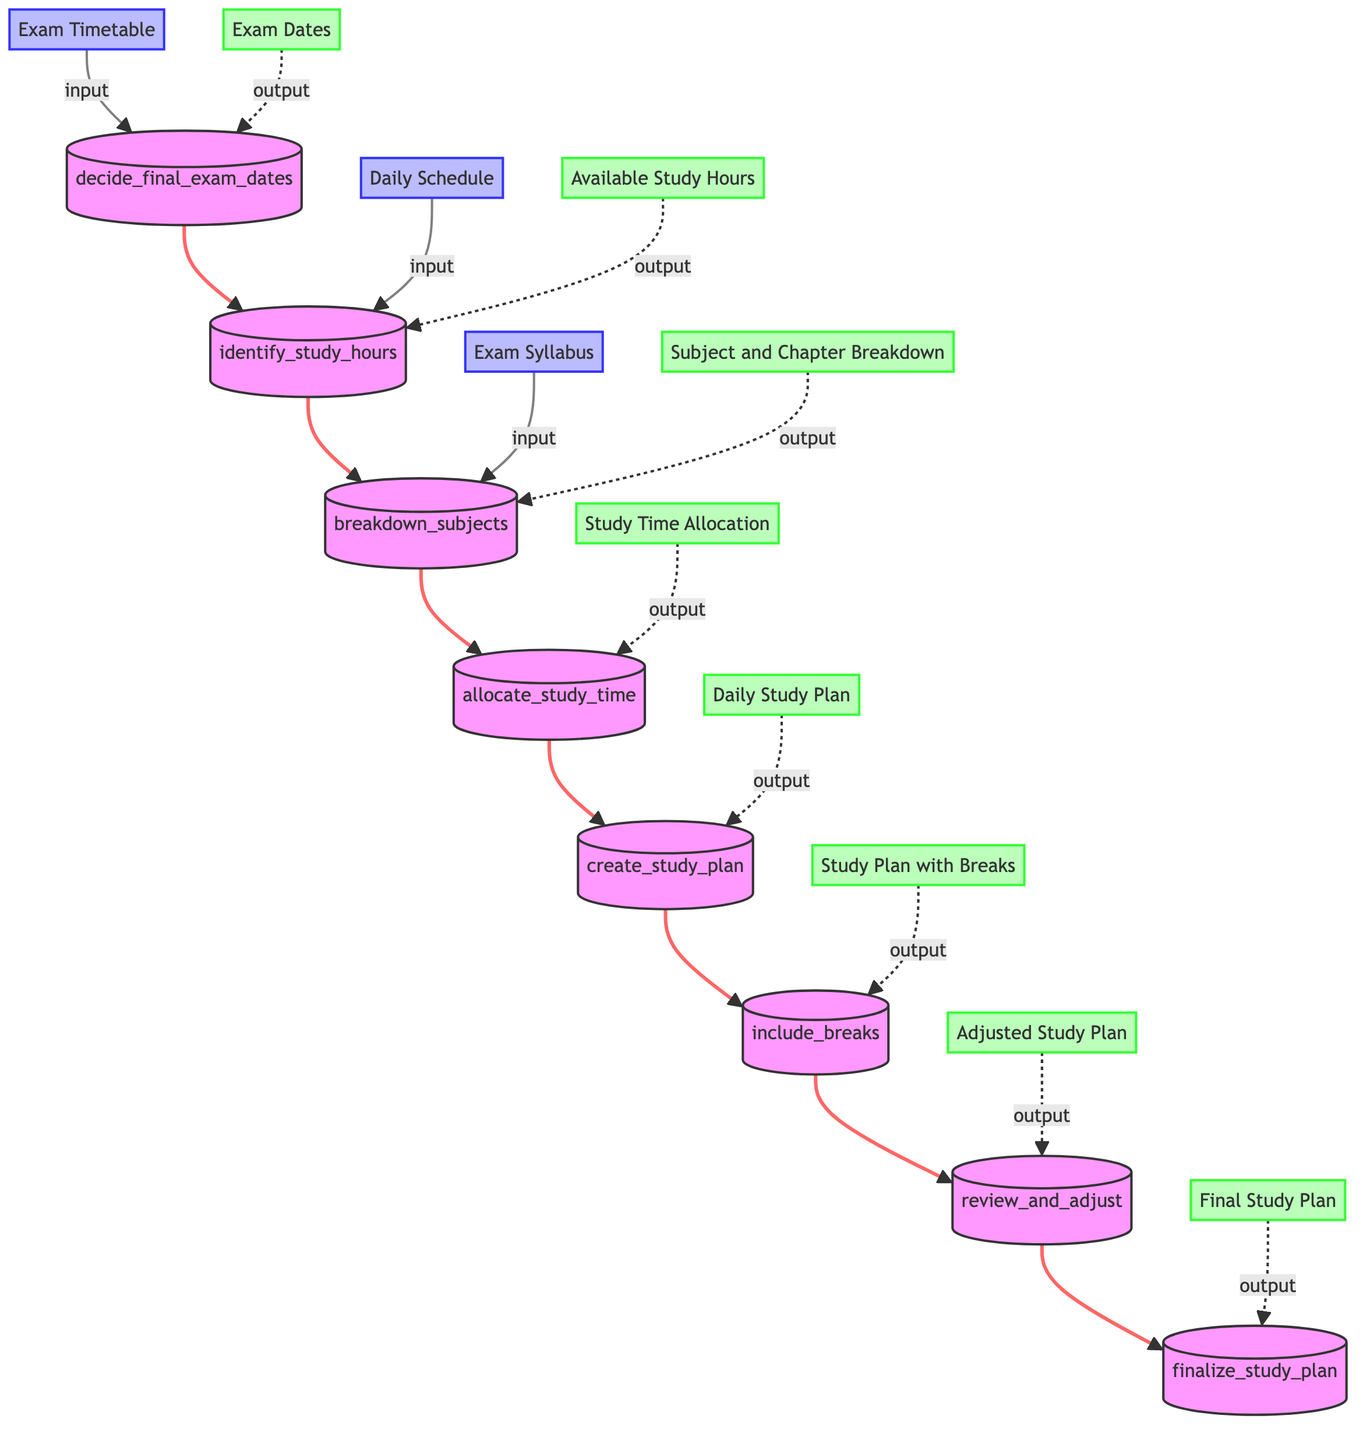What is the input for the first node? The first node, "decide_final_exam_dates," requires the input "Exam Timetable" to initiate the process of planning the study schedule.
Answer: Exam Timetable How many output nodes are there? There are eight output nodes in the flowchart, each one corresponding to the outputs of the various functions in the study schedule planning process.
Answer: Eight What is the output of the "allocate_study_time" node? The "allocate_study_time" node produces the output "Study Time Allocation," which is the result of distributing study hours based on importance and difficulty.
Answer: Study Time Allocation Which node follows "create_study_plan"? The node that follows "create_study_plan" is "include_breaks," which adds breaks to the study schedule to ensure it is balanced and sustainable.
Answer: include_breaks What do you input into the "review_and_adjust" node? The input for the "review_and_adjust" node is "Study Plan with Breaks," which is the result of incorporating breaks into the initial study plan.
Answer: Study Plan with Breaks What is the final output of the entire flowchart? The final output of the flowchart is "Final Study Plan," representing the completed study plan after all adjustments and reviews have been made.
Answer: Final Study Plan What output should be expected after "breakdown_subjects"? After processing through the "breakdown_subjects" node, the expected output is "Subject and Chapter Breakdown," which details the subjects and chapters to study.
Answer: Subject and Chapter Breakdown Which node requires both "Available Study Hours" and "Subject and Chapter Breakdown"? The "allocate_study_time" node requires both "Available Study Hours" and "Subject and Chapter Breakdown" as inputs to allocate study time effectively across subjects.
Answer: allocate_study_time 